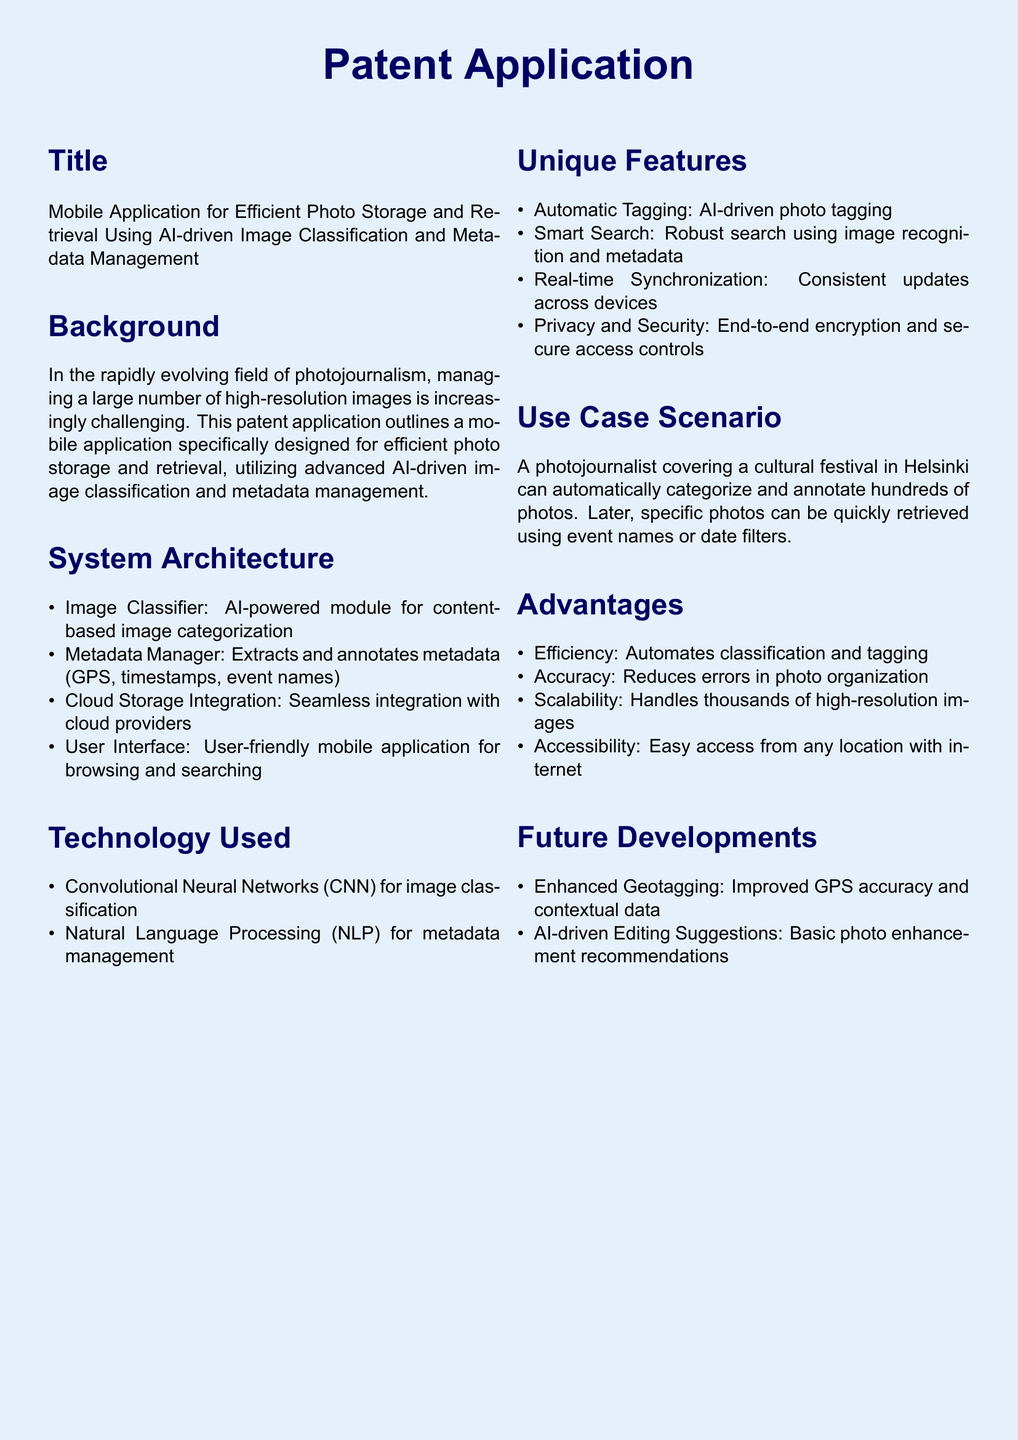What is the title of the patent application? The title is explicitly mentioned in the document under the Title section.
Answer: Mobile Application for Efficient Photo Storage and Retrieval Using AI-driven Image Classification and Metadata Management What technology is used for image classification? The document specifies the technology used for image classification within the Technology Used section.
Answer: Convolutional Neural Networks What is one of the unique features of the application? The unique features section lists several features; one is provided in this section.
Answer: Automatic Tagging What is the use case scenario mentioned in the document? The use case scenario describes a practical application of the mobile app as stated in the Use Case Scenario section.
Answer: A photojournalist covering a cultural festival in Helsinki How does the application ensure privacy and security? The document mentions specific measures taken for privacy and security in the Unique Features section.
Answer: End-to-end encryption What is a future development mention for the application? One of the future developments proposed in the Future Developments section can be cited here.
Answer: Enhanced Geotagging What aspect of photo management does the application aim to improve? The Background section outlines the challenges in photo management that the application addresses.
Answer: Efficiency How does the app achieve smart search functionality? The Unique Features section indicates how this key function is enabled within the app.
Answer: Using image recognition and metadata 